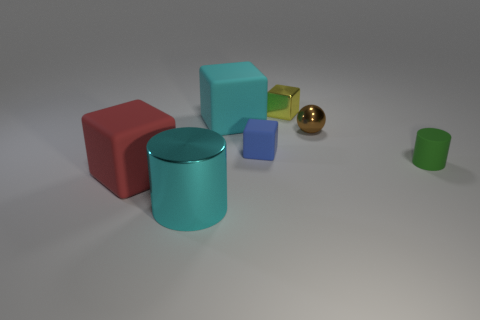Add 1 yellow things. How many objects exist? 8 Subtract all cubes. How many objects are left? 3 Add 4 tiny blue rubber cubes. How many tiny blue rubber cubes exist? 5 Subtract 0 yellow cylinders. How many objects are left? 7 Subtract all large things. Subtract all matte cubes. How many objects are left? 1 Add 3 tiny brown balls. How many tiny brown balls are left? 4 